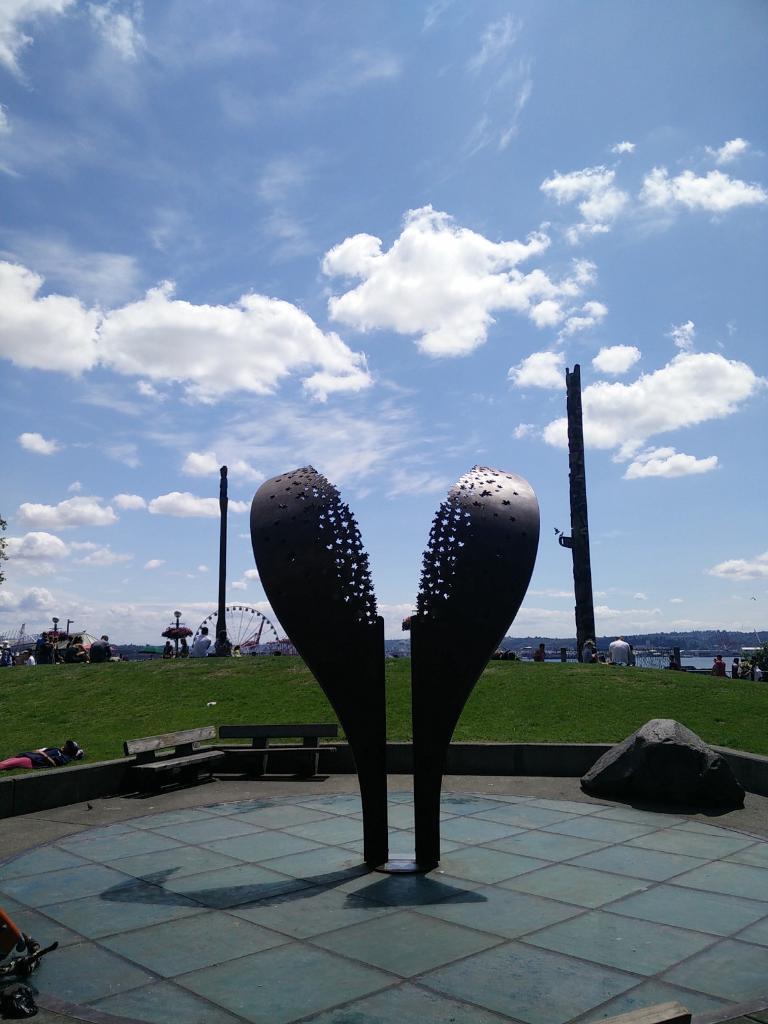In one or two sentences, can you explain what this image depicts? In this image in the center there are some statues and in the background there are some trees and some persons and one giant will, and on the right side and left side there are two poles. At the bottom there is a floor and on the right side there are two benches, and in the center there is grass. On the top of the image there is sky. 